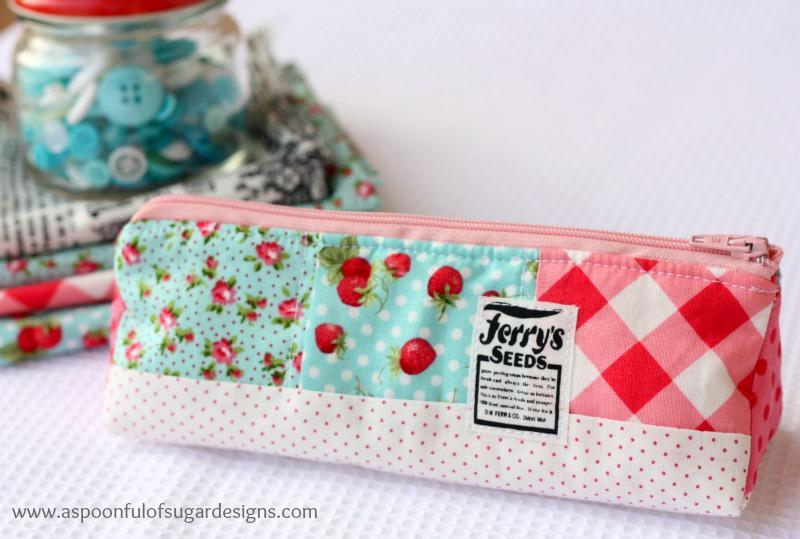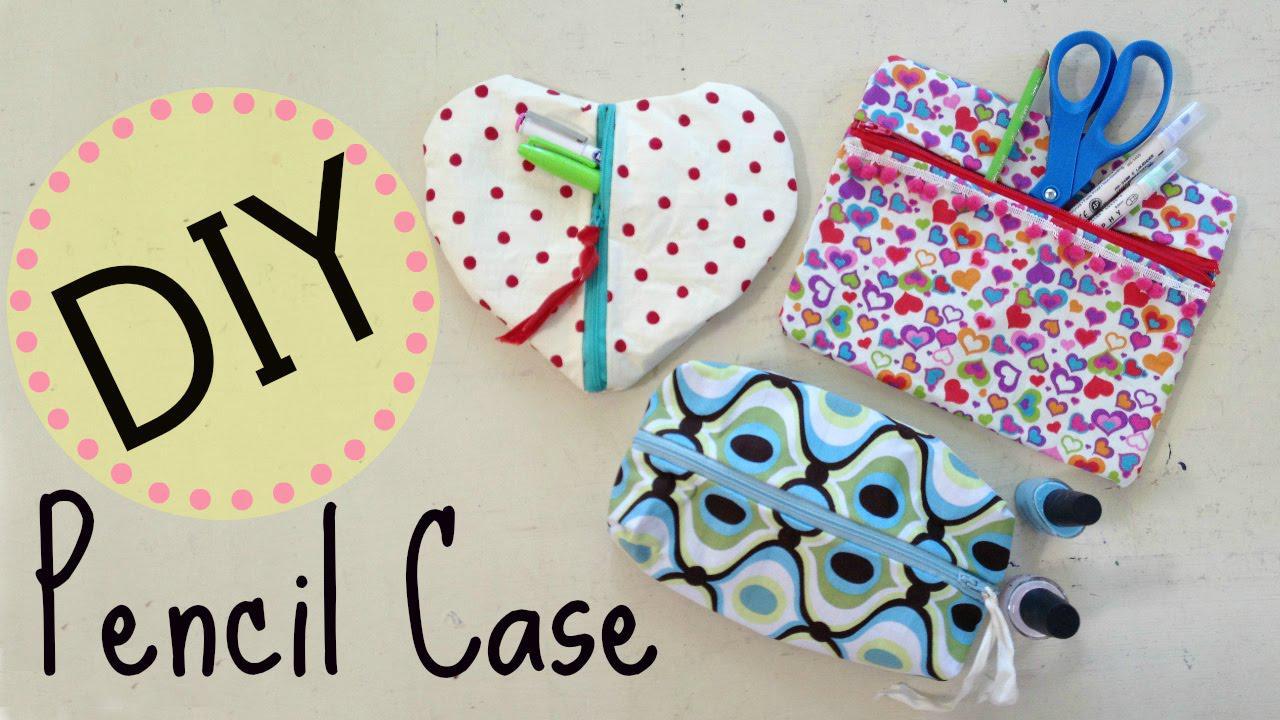The first image is the image on the left, the second image is the image on the right. Examine the images to the left and right. Is the description "A hand is touching at least one rectangular patterned item in one image." accurate? Answer yes or no. No. The first image is the image on the left, the second image is the image on the right. Considering the images on both sides, is "A human hand is touchin a school supply." valid? Answer yes or no. No. 